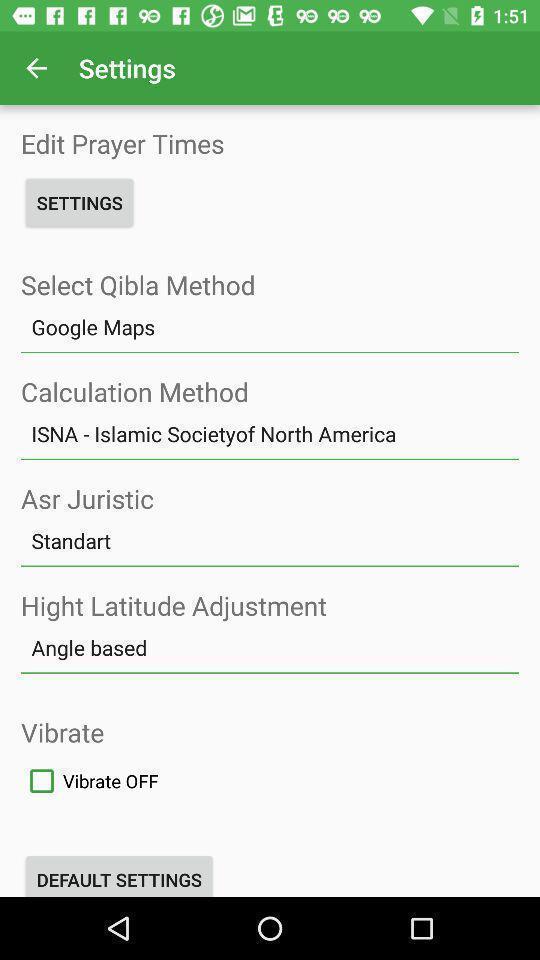Tell me about the visual elements in this screen capture. Settings page of religious application. 